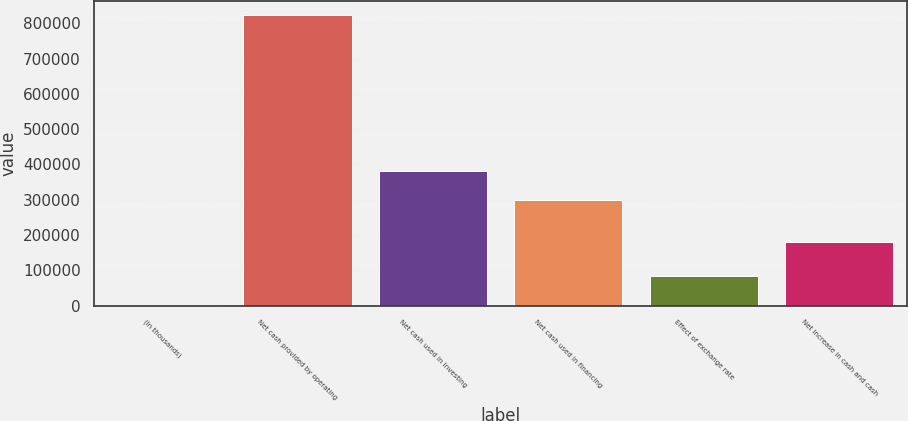<chart> <loc_0><loc_0><loc_500><loc_500><bar_chart><fcel>(In thousands)<fcel>Net cash provided by operating<fcel>Net cash used in investing<fcel>Net cash used in financing<fcel>Effect of exchange rate<fcel>Net increase in cash and cash<nl><fcel>2011<fcel>823166<fcel>382270<fcel>300155<fcel>84126.5<fcel>181411<nl></chart> 